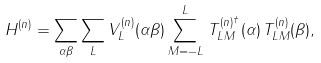Convert formula to latex. <formula><loc_0><loc_0><loc_500><loc_500>H ^ { ( n ) } = \sum _ { \alpha \beta } \sum _ { L } V _ { L } ^ { ( n ) } ( \alpha \beta ) \sum _ { M = - L } ^ { L } \, T _ { L M } ^ { ( n ) ^ { \dagger } } ( \alpha ) \, T _ { L M } ^ { ( n ) } ( \beta ) ,</formula> 